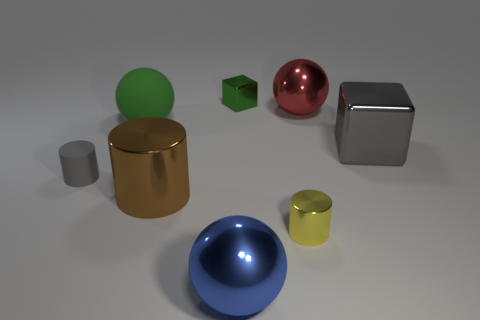Subtract all large green spheres. How many spheres are left? 2 Subtract 1 spheres. How many spheres are left? 2 Add 1 metallic cubes. How many objects exist? 9 Subtract all red cylinders. Subtract all blue spheres. How many cylinders are left? 3 Subtract all cylinders. How many objects are left? 5 Add 1 small gray cylinders. How many small gray cylinders exist? 2 Subtract 1 green balls. How many objects are left? 7 Subtract all small green matte blocks. Subtract all large red objects. How many objects are left? 7 Add 3 large brown cylinders. How many large brown cylinders are left? 4 